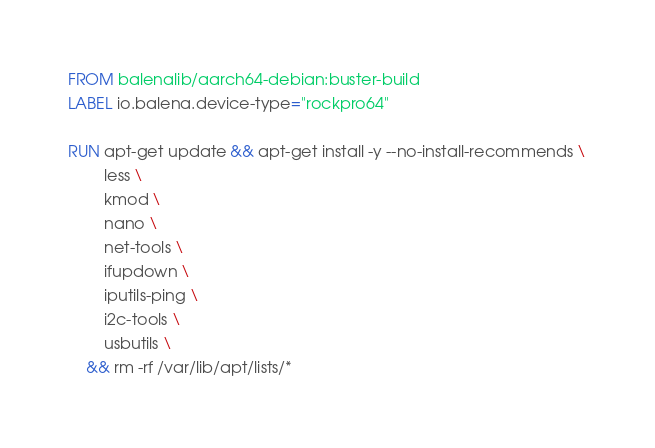Convert code to text. <code><loc_0><loc_0><loc_500><loc_500><_Dockerfile_>FROM balenalib/aarch64-debian:buster-build
LABEL io.balena.device-type="rockpro64"

RUN apt-get update && apt-get install -y --no-install-recommends \
		less \
		kmod \
		nano \
		net-tools \
		ifupdown \
		iputils-ping \
		i2c-tools \
		usbutils \
	&& rm -rf /var/lib/apt/lists/*
</code> 